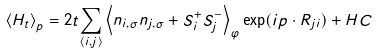Convert formula to latex. <formula><loc_0><loc_0><loc_500><loc_500>\left \langle H _ { t } \right \rangle _ { p } = 2 t \underset { \left \langle i , j \right \rangle } { \sum } \left \langle n _ { i , \sigma } n _ { j , \sigma } + S _ { i } ^ { + } S _ { j } ^ { - } \right \rangle _ { \varphi } \exp ( i p \cdot R _ { j i } ) + H C</formula> 